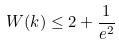<formula> <loc_0><loc_0><loc_500><loc_500>W ( k ) \leq 2 + \frac { 1 } { e ^ { 2 } }</formula> 